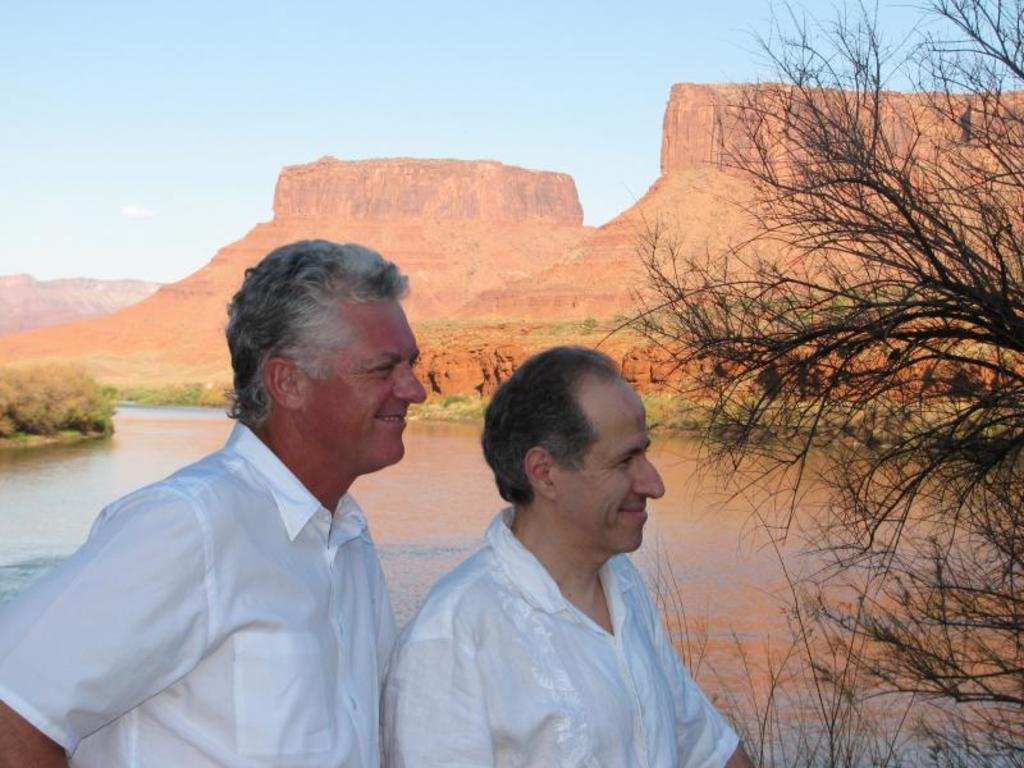Who or what can be seen in the image? There are people in the image. What can be seen in the distance behind the people? There are trees and hills visible in the background of the image. What natural element is present in the image? There is water visible in the image. What type of comb is being used by the person in the image? There is no comb present in the image. How does the person in the image react to the situation? The image does not depict a specific situation or reaction, so it cannot be determined from the image. 